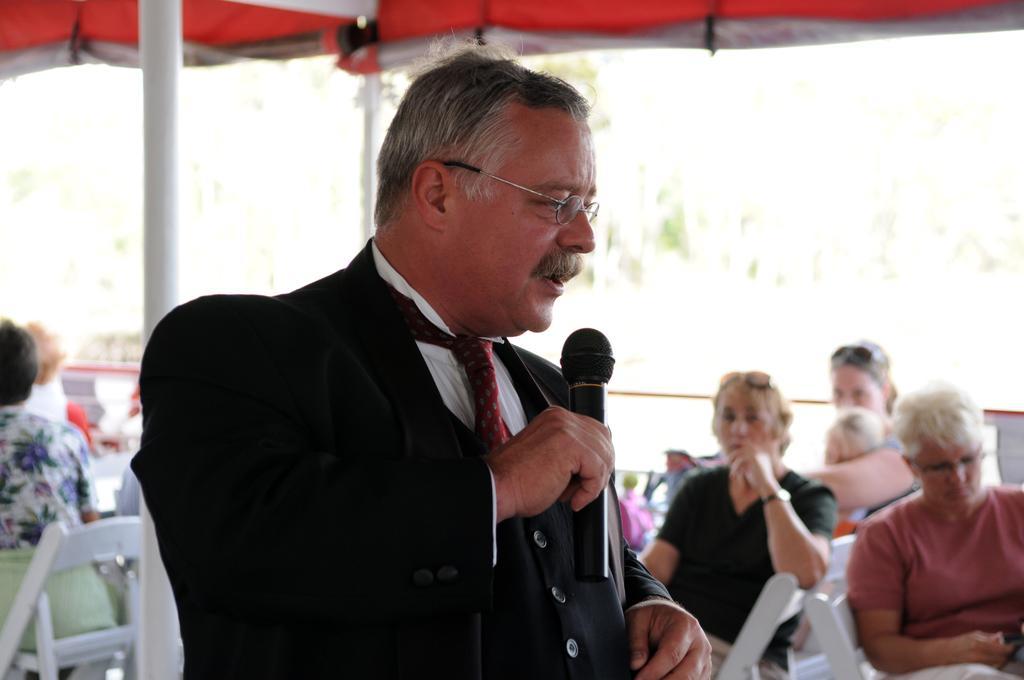Please provide a concise description of this image. Here in the front we can see a man speaking into microphone present in his hand and behind him we can see group of people sitting on chairs 